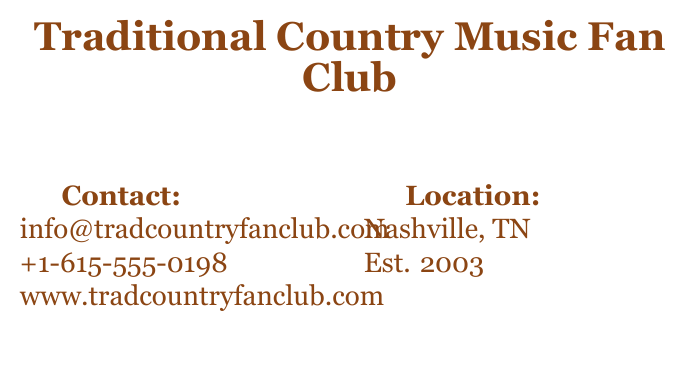What is the name of the fan club? The name of the fan club is stated clearly at the top of the card.
Answer: Traditional Country Music Fan Club Who is the founder of the fan club? The document mentions the founder in the designated section.
Answer: Alex Smith What is the contact email for the fan club? The contact email is provided in the contact section.
Answer: info@tradcountryfanclub.com In which city is the fan club located? The location is specified in the location section.
Answer: Nashville, TN When was the fan club established? The establishment date is indicated in the location section.
Answer: Est. 2003 What is the fan club's slogan? The slogan can be found in the center of the card.
Answer: "Celebrating the true spirit of country music" How many social media platforms are listed? The number of social media links can be counted in the social media section.
Answer: Three What color is used for the contact information? The color for the text in the contact section can be found in the document.
Answer: countrybrown What is the primary purpose stated on the card? The purpose of joining the fan club is mentioned at the bottom of the card.
Answer: Keep tradition alive 